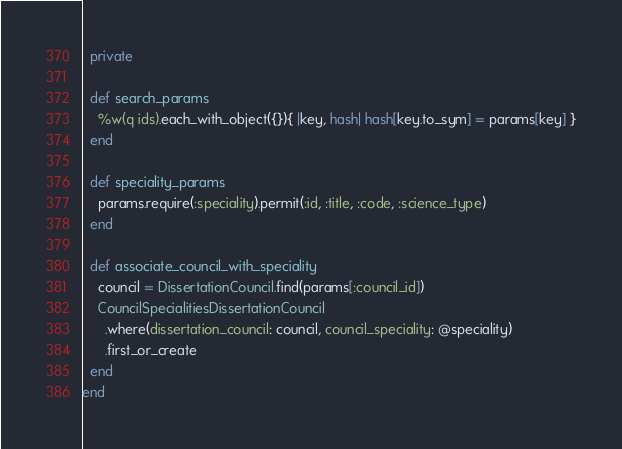Convert code to text. <code><loc_0><loc_0><loc_500><loc_500><_Ruby_>  private

  def search_params
    %w(q ids).each_with_object({}){ |key, hash| hash[key.to_sym] = params[key] }
  end

  def speciality_params
    params.require(:speciality).permit(:id, :title, :code, :science_type)
  end

  def associate_council_with_speciality
    council = DissertationCouncil.find(params[:council_id])
    CouncilSpecialitiesDissertationCouncil
      .where(dissertation_council: council, council_speciality: @speciality)
      .first_or_create
  end
end
</code> 